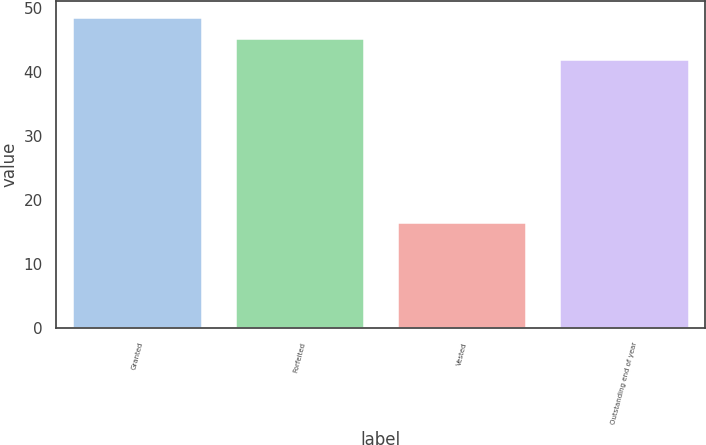Convert chart to OTSL. <chart><loc_0><loc_0><loc_500><loc_500><bar_chart><fcel>Granted<fcel>Forfeited<fcel>Vested<fcel>Outstanding end of year<nl><fcel>48.59<fcel>45.27<fcel>16.51<fcel>42.06<nl></chart> 